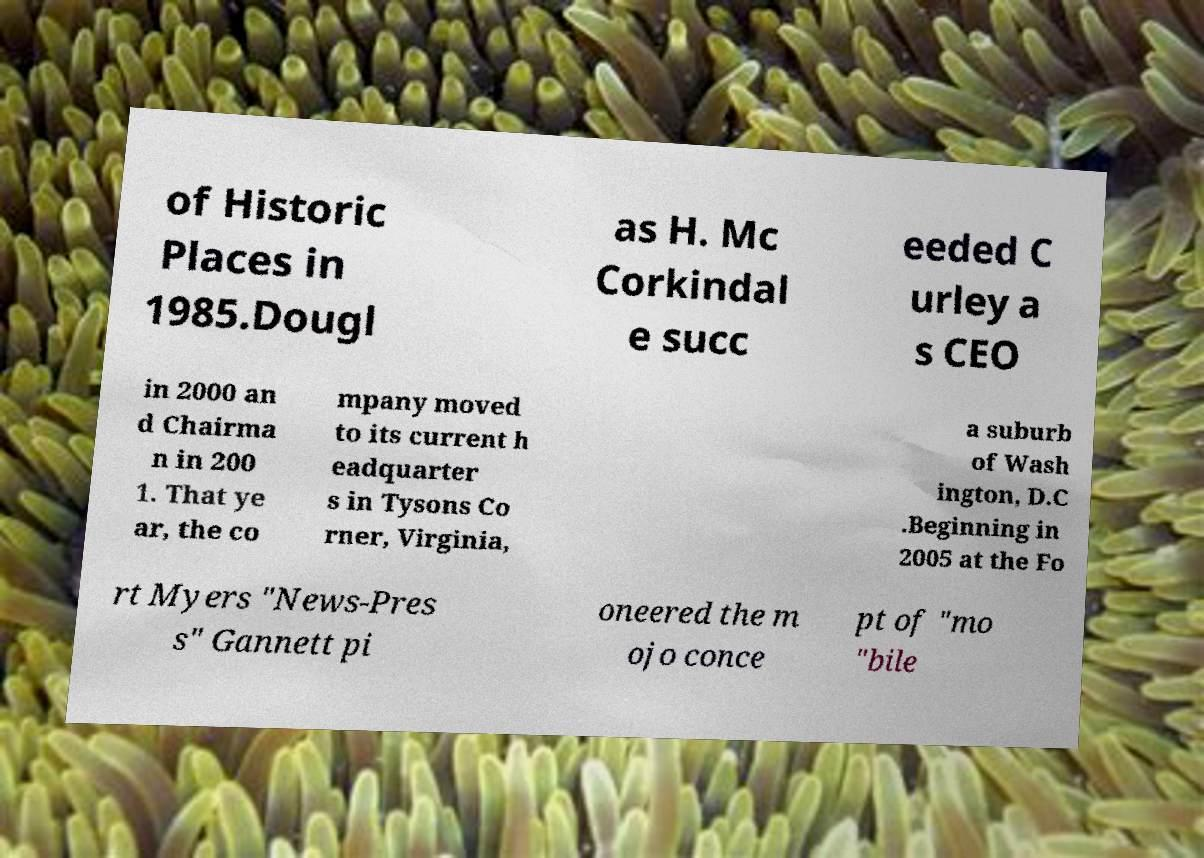Please read and relay the text visible in this image. What does it say? of Historic Places in 1985.Dougl as H. Mc Corkindal e succ eeded C urley a s CEO in 2000 an d Chairma n in 200 1. That ye ar, the co mpany moved to its current h eadquarter s in Tysons Co rner, Virginia, a suburb of Wash ington, D.C .Beginning in 2005 at the Fo rt Myers "News-Pres s" Gannett pi oneered the m ojo conce pt of "mo "bile 